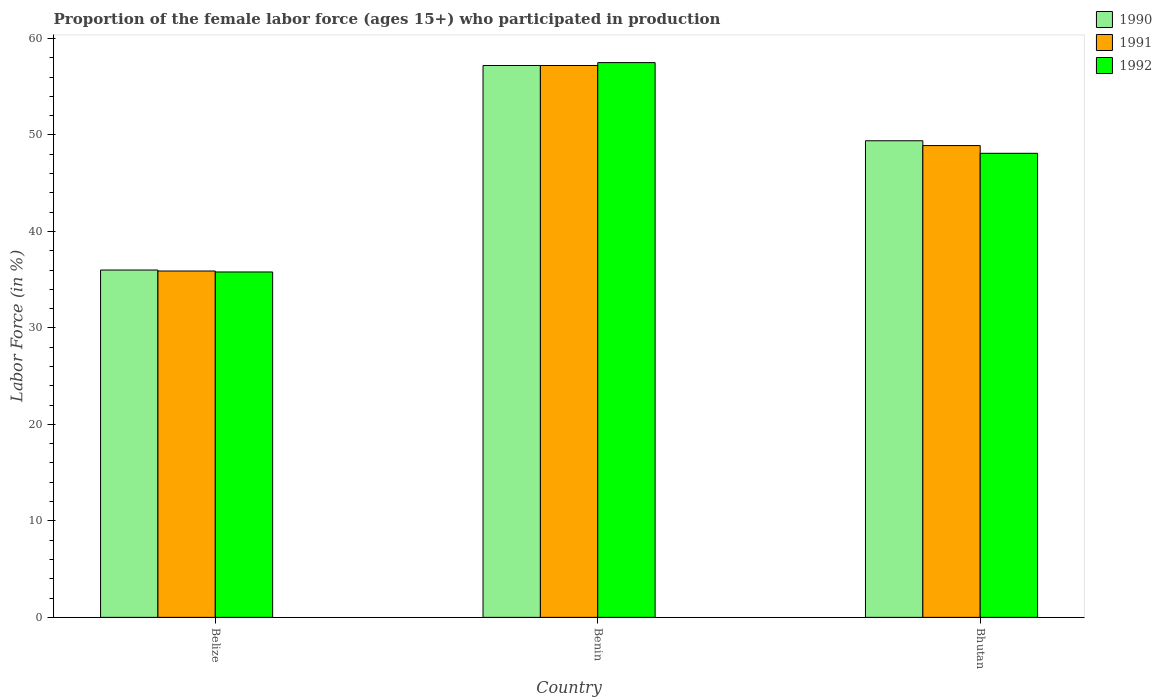How many groups of bars are there?
Offer a terse response. 3. Are the number of bars on each tick of the X-axis equal?
Give a very brief answer. Yes. How many bars are there on the 2nd tick from the left?
Keep it short and to the point. 3. How many bars are there on the 3rd tick from the right?
Give a very brief answer. 3. What is the label of the 3rd group of bars from the left?
Make the answer very short. Bhutan. What is the proportion of the female labor force who participated in production in 1990 in Bhutan?
Your response must be concise. 49.4. Across all countries, what is the maximum proportion of the female labor force who participated in production in 1990?
Offer a terse response. 57.2. In which country was the proportion of the female labor force who participated in production in 1992 maximum?
Your answer should be compact. Benin. In which country was the proportion of the female labor force who participated in production in 1990 minimum?
Your response must be concise. Belize. What is the total proportion of the female labor force who participated in production in 1990 in the graph?
Your answer should be compact. 142.6. What is the difference between the proportion of the female labor force who participated in production in 1991 in Belize and that in Bhutan?
Give a very brief answer. -13. What is the difference between the proportion of the female labor force who participated in production in 1992 in Bhutan and the proportion of the female labor force who participated in production in 1990 in Belize?
Keep it short and to the point. 12.1. What is the average proportion of the female labor force who participated in production in 1990 per country?
Make the answer very short. 47.53. What is the difference between the proportion of the female labor force who participated in production of/in 1990 and proportion of the female labor force who participated in production of/in 1992 in Belize?
Keep it short and to the point. 0.2. What is the ratio of the proportion of the female labor force who participated in production in 1990 in Benin to that in Bhutan?
Make the answer very short. 1.16. Is the proportion of the female labor force who participated in production in 1991 in Benin less than that in Bhutan?
Keep it short and to the point. No. What is the difference between the highest and the second highest proportion of the female labor force who participated in production in 1992?
Provide a short and direct response. -9.4. What is the difference between the highest and the lowest proportion of the female labor force who participated in production in 1991?
Offer a very short reply. 21.3. In how many countries, is the proportion of the female labor force who participated in production in 1991 greater than the average proportion of the female labor force who participated in production in 1991 taken over all countries?
Give a very brief answer. 2. What does the 3rd bar from the left in Belize represents?
Your response must be concise. 1992. Is it the case that in every country, the sum of the proportion of the female labor force who participated in production in 1991 and proportion of the female labor force who participated in production in 1992 is greater than the proportion of the female labor force who participated in production in 1990?
Make the answer very short. Yes. Are all the bars in the graph horizontal?
Your response must be concise. No. How many countries are there in the graph?
Your answer should be compact. 3. What is the difference between two consecutive major ticks on the Y-axis?
Your answer should be very brief. 10. Are the values on the major ticks of Y-axis written in scientific E-notation?
Your answer should be very brief. No. Does the graph contain any zero values?
Your answer should be compact. No. How many legend labels are there?
Give a very brief answer. 3. How are the legend labels stacked?
Your answer should be compact. Vertical. What is the title of the graph?
Ensure brevity in your answer.  Proportion of the female labor force (ages 15+) who participated in production. What is the label or title of the X-axis?
Offer a very short reply. Country. What is the Labor Force (in %) in 1990 in Belize?
Ensure brevity in your answer.  36. What is the Labor Force (in %) of 1991 in Belize?
Give a very brief answer. 35.9. What is the Labor Force (in %) in 1992 in Belize?
Your answer should be very brief. 35.8. What is the Labor Force (in %) in 1990 in Benin?
Provide a short and direct response. 57.2. What is the Labor Force (in %) of 1991 in Benin?
Give a very brief answer. 57.2. What is the Labor Force (in %) of 1992 in Benin?
Your response must be concise. 57.5. What is the Labor Force (in %) in 1990 in Bhutan?
Make the answer very short. 49.4. What is the Labor Force (in %) in 1991 in Bhutan?
Your response must be concise. 48.9. What is the Labor Force (in %) of 1992 in Bhutan?
Offer a very short reply. 48.1. Across all countries, what is the maximum Labor Force (in %) of 1990?
Ensure brevity in your answer.  57.2. Across all countries, what is the maximum Labor Force (in %) in 1991?
Ensure brevity in your answer.  57.2. Across all countries, what is the maximum Labor Force (in %) of 1992?
Offer a very short reply. 57.5. Across all countries, what is the minimum Labor Force (in %) in 1991?
Give a very brief answer. 35.9. Across all countries, what is the minimum Labor Force (in %) of 1992?
Your answer should be very brief. 35.8. What is the total Labor Force (in %) in 1990 in the graph?
Your response must be concise. 142.6. What is the total Labor Force (in %) in 1991 in the graph?
Offer a terse response. 142. What is the total Labor Force (in %) in 1992 in the graph?
Provide a succinct answer. 141.4. What is the difference between the Labor Force (in %) of 1990 in Belize and that in Benin?
Ensure brevity in your answer.  -21.2. What is the difference between the Labor Force (in %) in 1991 in Belize and that in Benin?
Give a very brief answer. -21.3. What is the difference between the Labor Force (in %) of 1992 in Belize and that in Benin?
Provide a short and direct response. -21.7. What is the difference between the Labor Force (in %) in 1990 in Belize and that in Bhutan?
Your answer should be compact. -13.4. What is the difference between the Labor Force (in %) of 1991 in Belize and that in Bhutan?
Offer a terse response. -13. What is the difference between the Labor Force (in %) in 1992 in Belize and that in Bhutan?
Your answer should be compact. -12.3. What is the difference between the Labor Force (in %) in 1990 in Benin and that in Bhutan?
Provide a short and direct response. 7.8. What is the difference between the Labor Force (in %) of 1991 in Benin and that in Bhutan?
Provide a short and direct response. 8.3. What is the difference between the Labor Force (in %) of 1992 in Benin and that in Bhutan?
Offer a terse response. 9.4. What is the difference between the Labor Force (in %) of 1990 in Belize and the Labor Force (in %) of 1991 in Benin?
Offer a terse response. -21.2. What is the difference between the Labor Force (in %) in 1990 in Belize and the Labor Force (in %) in 1992 in Benin?
Your answer should be compact. -21.5. What is the difference between the Labor Force (in %) in 1991 in Belize and the Labor Force (in %) in 1992 in Benin?
Offer a terse response. -21.6. What is the difference between the Labor Force (in %) in 1990 in Belize and the Labor Force (in %) in 1992 in Bhutan?
Make the answer very short. -12.1. What is the difference between the Labor Force (in %) in 1991 in Belize and the Labor Force (in %) in 1992 in Bhutan?
Offer a terse response. -12.2. What is the difference between the Labor Force (in %) in 1991 in Benin and the Labor Force (in %) in 1992 in Bhutan?
Offer a terse response. 9.1. What is the average Labor Force (in %) in 1990 per country?
Provide a succinct answer. 47.53. What is the average Labor Force (in %) of 1991 per country?
Ensure brevity in your answer.  47.33. What is the average Labor Force (in %) in 1992 per country?
Offer a terse response. 47.13. What is the difference between the Labor Force (in %) in 1990 and Labor Force (in %) in 1992 in Belize?
Offer a terse response. 0.2. What is the difference between the Labor Force (in %) in 1991 and Labor Force (in %) in 1992 in Belize?
Provide a short and direct response. 0.1. What is the difference between the Labor Force (in %) in 1990 and Labor Force (in %) in 1991 in Benin?
Ensure brevity in your answer.  0. What is the difference between the Labor Force (in %) of 1990 and Labor Force (in %) of 1992 in Benin?
Offer a terse response. -0.3. What is the difference between the Labor Force (in %) in 1991 and Labor Force (in %) in 1992 in Benin?
Give a very brief answer. -0.3. What is the ratio of the Labor Force (in %) of 1990 in Belize to that in Benin?
Your response must be concise. 0.63. What is the ratio of the Labor Force (in %) of 1991 in Belize to that in Benin?
Provide a short and direct response. 0.63. What is the ratio of the Labor Force (in %) in 1992 in Belize to that in Benin?
Provide a short and direct response. 0.62. What is the ratio of the Labor Force (in %) in 1990 in Belize to that in Bhutan?
Make the answer very short. 0.73. What is the ratio of the Labor Force (in %) of 1991 in Belize to that in Bhutan?
Give a very brief answer. 0.73. What is the ratio of the Labor Force (in %) of 1992 in Belize to that in Bhutan?
Keep it short and to the point. 0.74. What is the ratio of the Labor Force (in %) in 1990 in Benin to that in Bhutan?
Your answer should be very brief. 1.16. What is the ratio of the Labor Force (in %) of 1991 in Benin to that in Bhutan?
Give a very brief answer. 1.17. What is the ratio of the Labor Force (in %) of 1992 in Benin to that in Bhutan?
Your answer should be compact. 1.2. What is the difference between the highest and the second highest Labor Force (in %) in 1990?
Give a very brief answer. 7.8. What is the difference between the highest and the second highest Labor Force (in %) of 1991?
Make the answer very short. 8.3. What is the difference between the highest and the second highest Labor Force (in %) in 1992?
Provide a succinct answer. 9.4. What is the difference between the highest and the lowest Labor Force (in %) in 1990?
Provide a succinct answer. 21.2. What is the difference between the highest and the lowest Labor Force (in %) of 1991?
Provide a succinct answer. 21.3. What is the difference between the highest and the lowest Labor Force (in %) of 1992?
Keep it short and to the point. 21.7. 